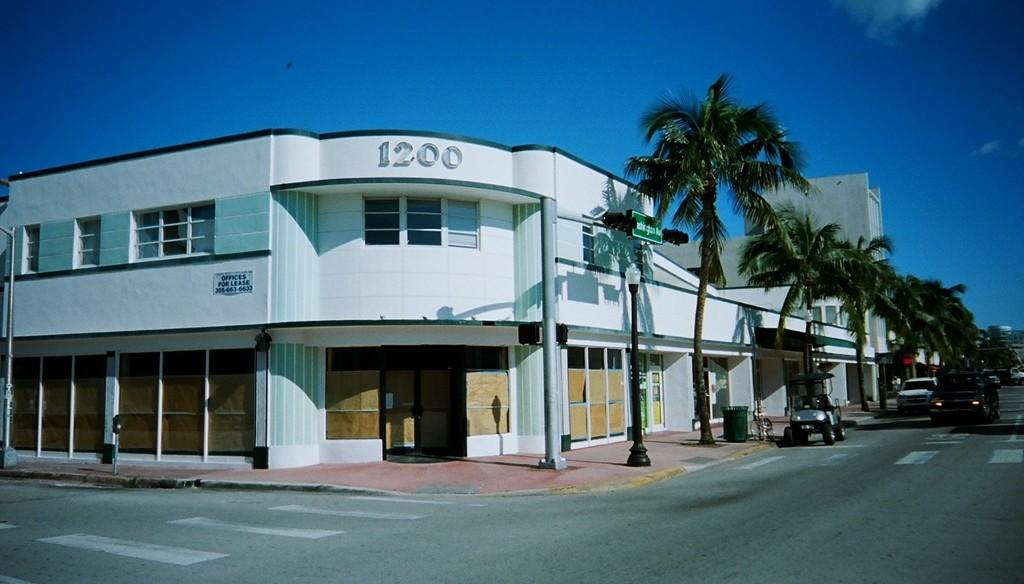What types of objects can be seen in the image? There are vehicles, trees, and buildings in the image. Can you describe the trees in the image? The trees have green color in the image. What is visible in the background of the image? The sky is visible in the image, with white and blue colors. How many chairs can be seen in the image? There are no chairs present in the image. What type of orange is visible in the image? There is no orange present in the image. 